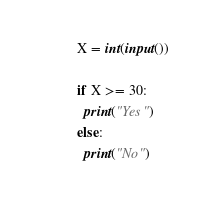<code> <loc_0><loc_0><loc_500><loc_500><_Python_>X = int(input())

if X >= 30:
  print("Yes")
else:
  print("No")</code> 